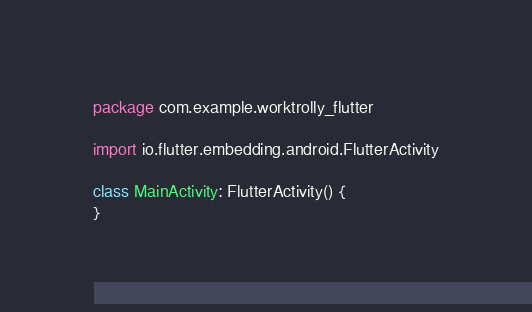<code> <loc_0><loc_0><loc_500><loc_500><_Kotlin_>package com.example.worktrolly_flutter

import io.flutter.embedding.android.FlutterActivity

class MainActivity: FlutterActivity() {
}
</code> 